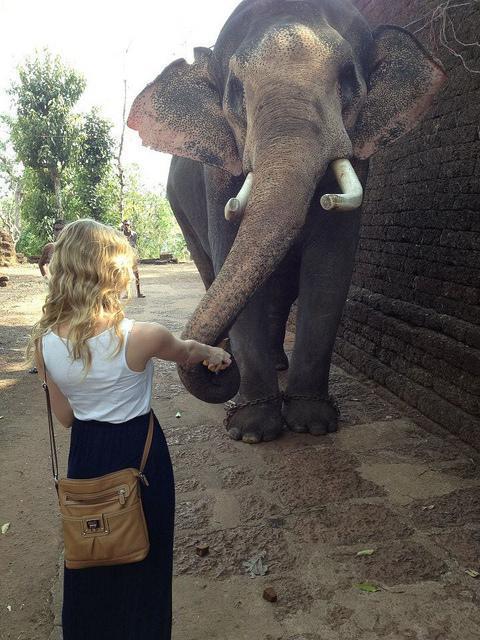How many tusk are visible?
Give a very brief answer. 2. How many color umbrellas are there in the image ?
Give a very brief answer. 0. 